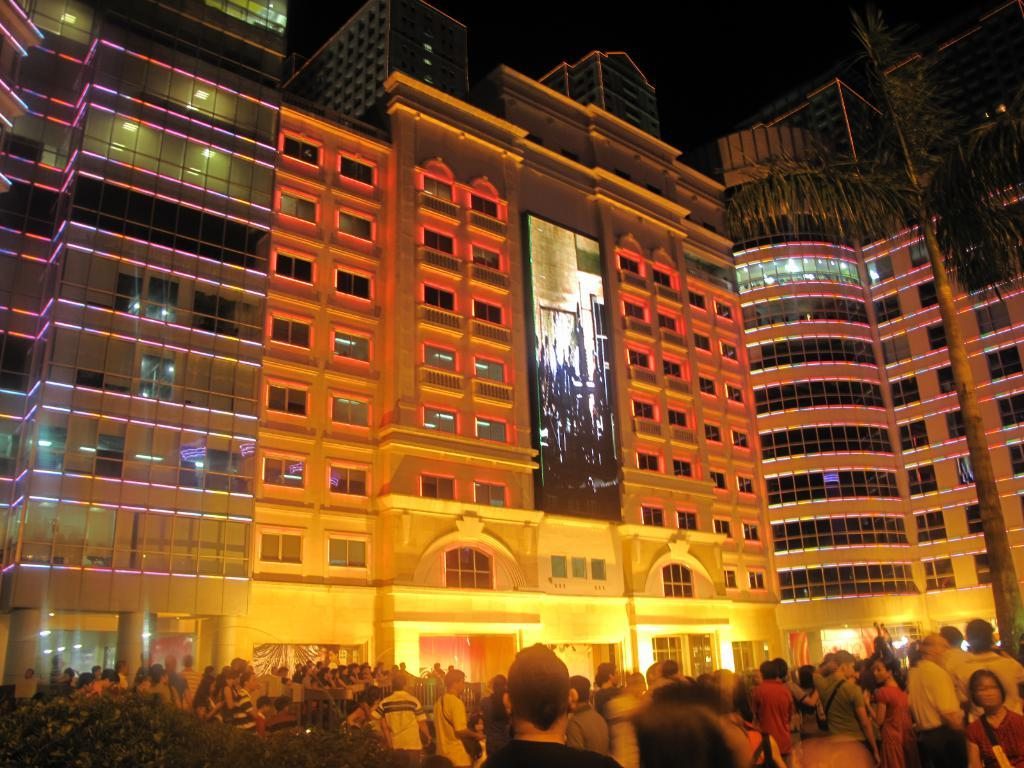What can be seen in the foreground of the picture? There are people and plants in the foreground of the picture. What is located in the center of the picture? There are buildings, lights, a screen, and plants in the center of the picture. What is the color of the sky in the picture? The sky is dark in the picture. What type of cabbage is being used to solve the riddle on the screen in the picture? There is no cabbage or riddle present on the screen in the picture. The screen is not mentioned to be displaying any riddle or cabbage-related content. 